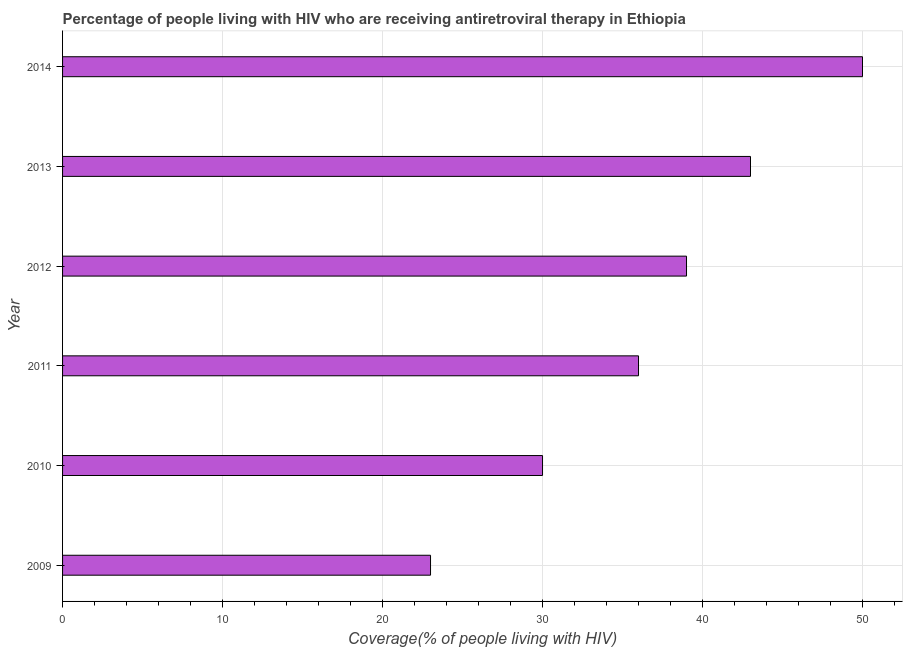What is the title of the graph?
Offer a terse response. Percentage of people living with HIV who are receiving antiretroviral therapy in Ethiopia. What is the label or title of the X-axis?
Give a very brief answer. Coverage(% of people living with HIV). What is the sum of the antiretroviral therapy coverage?
Your response must be concise. 221. What is the median antiretroviral therapy coverage?
Provide a succinct answer. 37.5. What is the ratio of the antiretroviral therapy coverage in 2010 to that in 2012?
Ensure brevity in your answer.  0.77. Is the sum of the antiretroviral therapy coverage in 2010 and 2011 greater than the maximum antiretroviral therapy coverage across all years?
Ensure brevity in your answer.  Yes. What is the difference between the highest and the lowest antiretroviral therapy coverage?
Make the answer very short. 27. What is the difference between two consecutive major ticks on the X-axis?
Provide a succinct answer. 10. What is the Coverage(% of people living with HIV) in 2011?
Provide a short and direct response. 36. What is the Coverage(% of people living with HIV) of 2013?
Provide a succinct answer. 43. What is the difference between the Coverage(% of people living with HIV) in 2009 and 2010?
Keep it short and to the point. -7. What is the difference between the Coverage(% of people living with HIV) in 2009 and 2012?
Your answer should be very brief. -16. What is the difference between the Coverage(% of people living with HIV) in 2009 and 2014?
Your answer should be compact. -27. What is the difference between the Coverage(% of people living with HIV) in 2010 and 2011?
Give a very brief answer. -6. What is the difference between the Coverage(% of people living with HIV) in 2010 and 2014?
Keep it short and to the point. -20. What is the difference between the Coverage(% of people living with HIV) in 2012 and 2014?
Offer a very short reply. -11. What is the difference between the Coverage(% of people living with HIV) in 2013 and 2014?
Provide a succinct answer. -7. What is the ratio of the Coverage(% of people living with HIV) in 2009 to that in 2010?
Your response must be concise. 0.77. What is the ratio of the Coverage(% of people living with HIV) in 2009 to that in 2011?
Ensure brevity in your answer.  0.64. What is the ratio of the Coverage(% of people living with HIV) in 2009 to that in 2012?
Your answer should be very brief. 0.59. What is the ratio of the Coverage(% of people living with HIV) in 2009 to that in 2013?
Ensure brevity in your answer.  0.54. What is the ratio of the Coverage(% of people living with HIV) in 2009 to that in 2014?
Ensure brevity in your answer.  0.46. What is the ratio of the Coverage(% of people living with HIV) in 2010 to that in 2011?
Offer a very short reply. 0.83. What is the ratio of the Coverage(% of people living with HIV) in 2010 to that in 2012?
Your answer should be compact. 0.77. What is the ratio of the Coverage(% of people living with HIV) in 2010 to that in 2013?
Offer a very short reply. 0.7. What is the ratio of the Coverage(% of people living with HIV) in 2011 to that in 2012?
Provide a short and direct response. 0.92. What is the ratio of the Coverage(% of people living with HIV) in 2011 to that in 2013?
Give a very brief answer. 0.84. What is the ratio of the Coverage(% of people living with HIV) in 2011 to that in 2014?
Keep it short and to the point. 0.72. What is the ratio of the Coverage(% of people living with HIV) in 2012 to that in 2013?
Give a very brief answer. 0.91. What is the ratio of the Coverage(% of people living with HIV) in 2012 to that in 2014?
Make the answer very short. 0.78. What is the ratio of the Coverage(% of people living with HIV) in 2013 to that in 2014?
Provide a short and direct response. 0.86. 